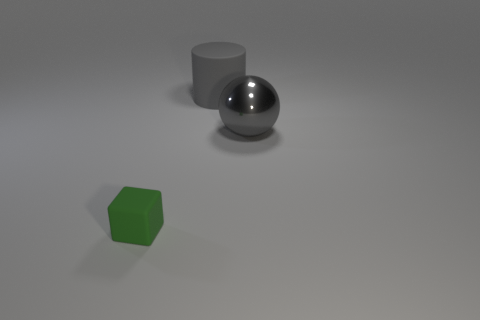Is there anything else that is the same size as the green cube?
Give a very brief answer. No. The large object that is the same color as the big matte cylinder is what shape?
Your answer should be compact. Sphere. What number of other things are there of the same size as the gray ball?
Make the answer very short. 1. What number of small things are gray objects or cyan metal cubes?
Offer a terse response. 0. Do the gray rubber cylinder and the matte object that is in front of the ball have the same size?
Your answer should be very brief. No. What number of other things are the same shape as the green object?
Your response must be concise. 0. The green object that is made of the same material as the large gray cylinder is what shape?
Offer a terse response. Cube. Are there any brown rubber things?
Your response must be concise. No. Is the number of green matte blocks to the left of the green rubber block less than the number of large gray things that are left of the gray metal sphere?
Keep it short and to the point. Yes. What is the shape of the large gray thing that is behind the big gray shiny ball?
Offer a terse response. Cylinder. 